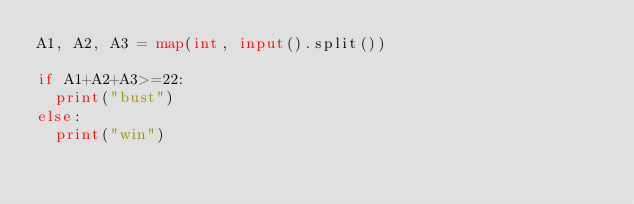<code> <loc_0><loc_0><loc_500><loc_500><_Python_>A1, A2, A3 = map(int, input().split())

if A1+A2+A3>=22:
  print("bust")
else:
  print("win")</code> 